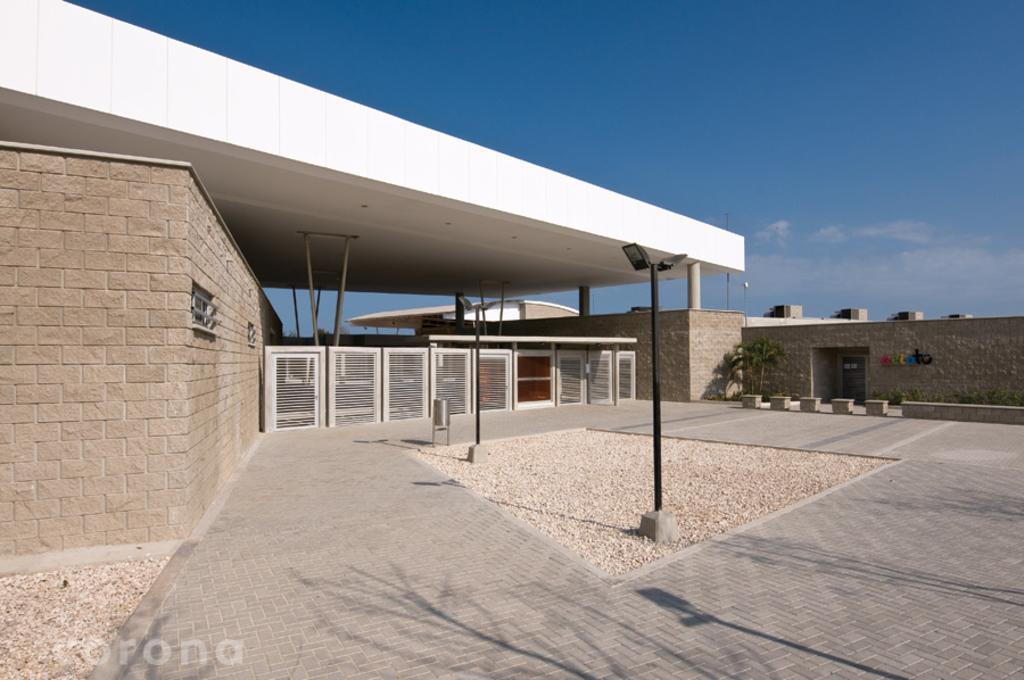Describe this image in one or two sentences. As we can see in the image there are buildings, plants and on the top there is a sky. 